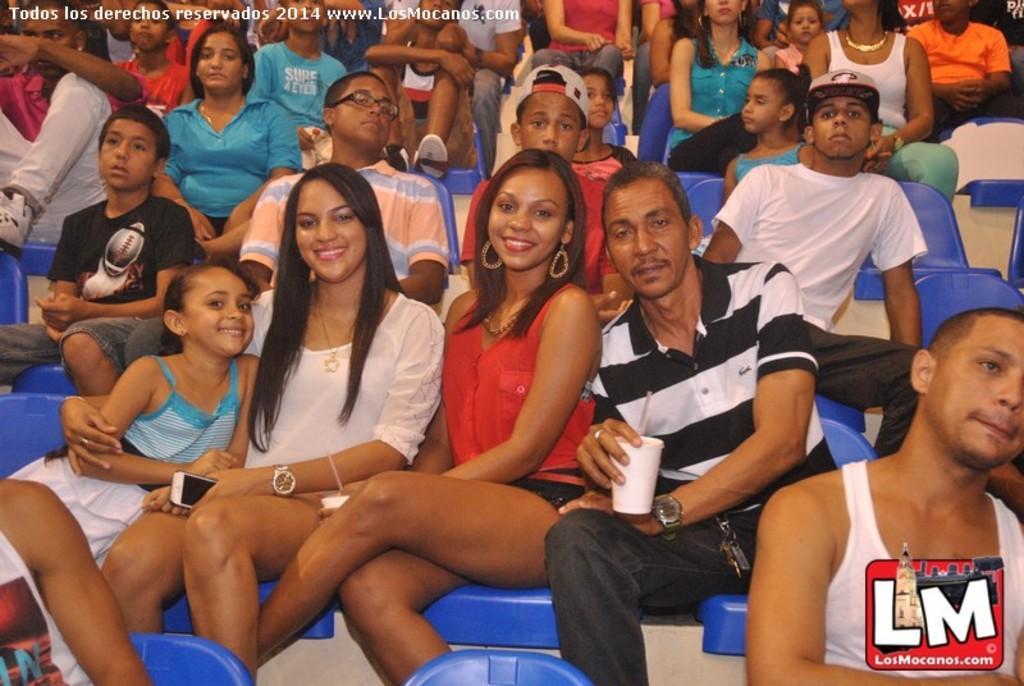In one or two sentences, can you explain what this image depicts? In this image we can see persons on the chairs. 